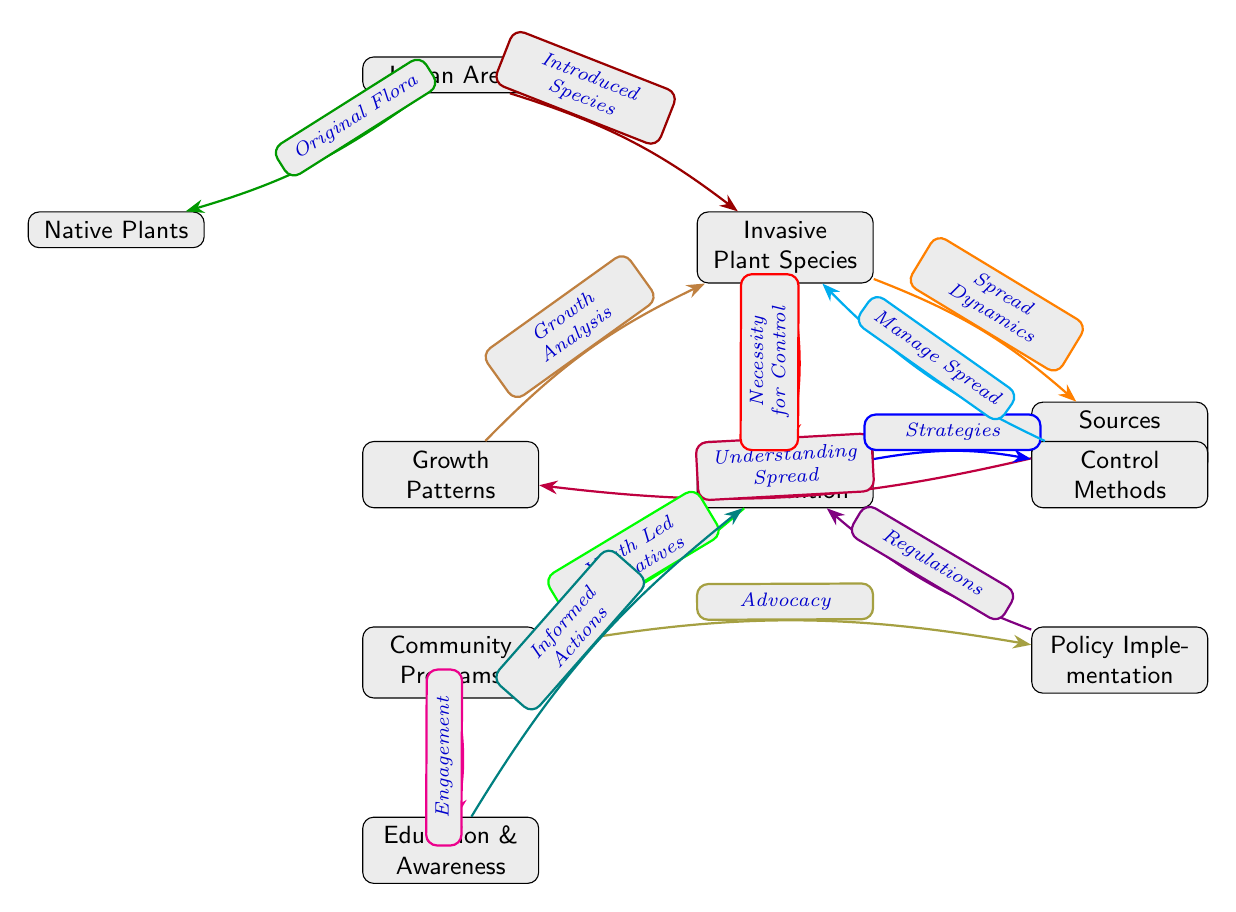What are the two main types of plants in the urban area? The diagram identifies two types of plants in the urban area: Native Plants and Invasive Plant Species, both of which are distinct nodes stemming from the Urban Area node.
Answer: Native Plants, Invasive Plant Species How many nodes are there in total in the diagram? By counting all the distinct nodes shown in the diagram, we find there are a total of 11 nodes, including the central Urban Area and the surrounding elements.
Answer: 11 What color represents the "Spread Dynamics"? The connection labeled "Spread Dynamics" is represented by the color orange, linking Invasive Plant Species to Sources of Spread.
Answer: Orange What leads to Human Intervention? The necessity for Human Intervention is indicated by the edge labeled "Necessity for Control," coming directly from the Invasive Plant Species node, signifying a direct relationship based on need for management.
Answer: Invasive Plant Species How does Education & Awareness relate to Community Programs? The diagram shows a direct relationship where the Community Programs node leads to the Education & Awareness node through an edge labeled "Engagement," indicating that engagement in community programs leads to informing the community.
Answer: Engagement Which method directly manages the spread of Invasive Plant Species? Control Methods are linked directly to Invasive Plant Species with an edge labeled "Manage Spread," indicating that these methods are intended to control or reduce the spread of invasive species.
Answer: Control Methods What is the significance of the edge labeled "Understanding Spread"? The "Understanding Spread" edge connects Sources of Spread and Growth Patterns, highlighting the importance of comprehending how invasive species spread and their respective growth patterns for effective management.
Answer: Understanding Spread What type of initiative is promoted under Human Intervention? Under the Human Intervention node, there is a connection labeled "Youth Led Initiatives," showing a focus on community engagement from a youth perspective.
Answer: Youth Led Initiatives How are regulations related to Human Intervention? The connection between Policy Implementation and Human Intervention indicates that established regulations play a crucial role in determining the methods and strategies employed for managing invasive species.
Answer: Regulations 